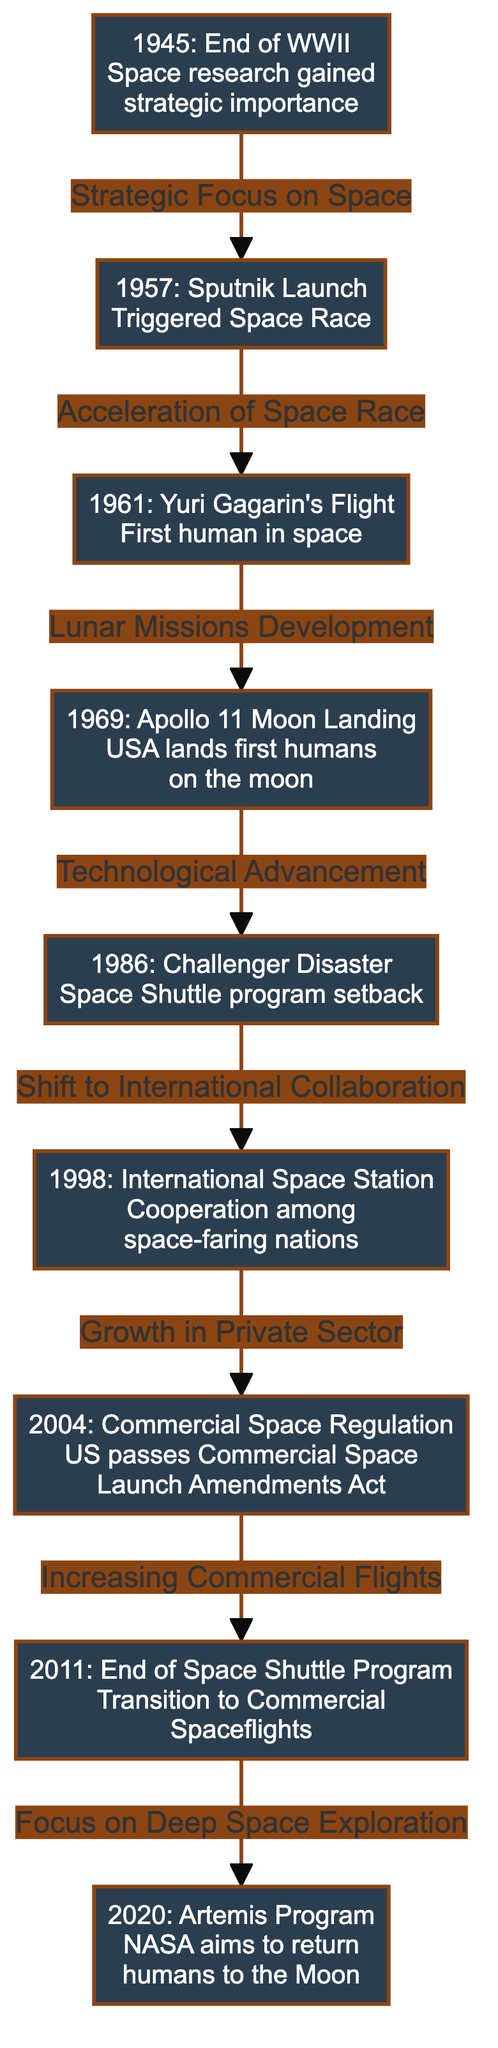What event triggered the Space Race? The diagram indicates that the launch of Sputnik in 1957 was the event that triggered the Space Race. This is shown as a direct connection following the 1945 node, which quotes a "Strategic Focus on Space" leading to the 1957 node.
Answer: Sputnik Launch Which year did Yuri Gagarin fly into space? The diagram explicitly lists 1961 next to the Yuri Gagarin's Flight node, indicating that it was the year of this significant event in space exploration.
Answer: 1961 What major setback occurred in the Space Shuttle program? According to the diagram, the Challenger Disaster in 1986 is noted as a major setback for the Space Shuttle program, creating a direct connection to the 1986 node from the 1969 node.
Answer: Challenger Disaster How many nodes are in the diagram? There are a total of eight nodes represented in the diagram, counting each distinct year and event connected in the timeline.
Answer: 8 What event followed the end of the Space Shuttle Program? In the flow of events shown in the diagram, the end of the Space Shuttle program in 2011 leads directly to a focus on deep space exploration illustrated by the 2020 node dedicated to the Artemis Program.
Answer: Focus on Deep Space Exploration What type of collaboration increased in 1998? The diagram indicates that the Challenger Disaster led to a shift to International Collaboration highlighted by the 1998 International Space Station node, making this a transition noted in the flow of events.
Answer: International Collaboration In what year did the USA land the first humans on the moon? The Apollo 11 Moon Landing is specifically stated in the 1969 node as the year when the USA achieved this milestone in space exploration.
Answer: 1969 Which political decision contributed to the growth in the private sector? The diagram indicates that the International Space Station's collaboration in 1998 resulted in growth within the private sector, as marked by the connection to the 2004 node concerning Commercial Space Regulation.
Answer: Growth in Private Sector 